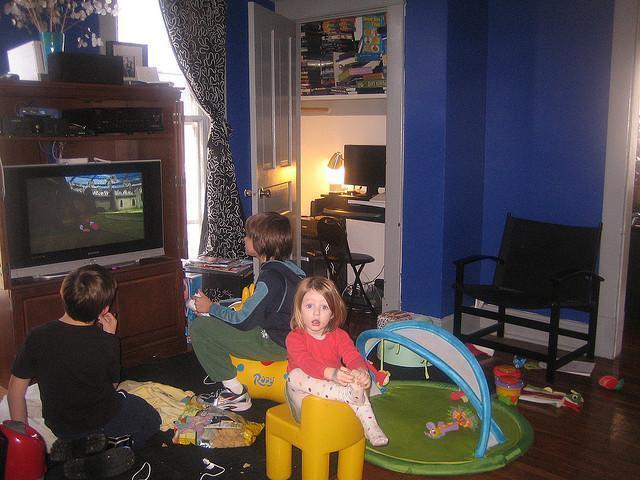How many kids are watching the TV?
Give a very brief answer. 2. How many people can you see?
Give a very brief answer. 3. How many chairs are in the picture?
Give a very brief answer. 3. How many black umbrellas are there?
Give a very brief answer. 0. 